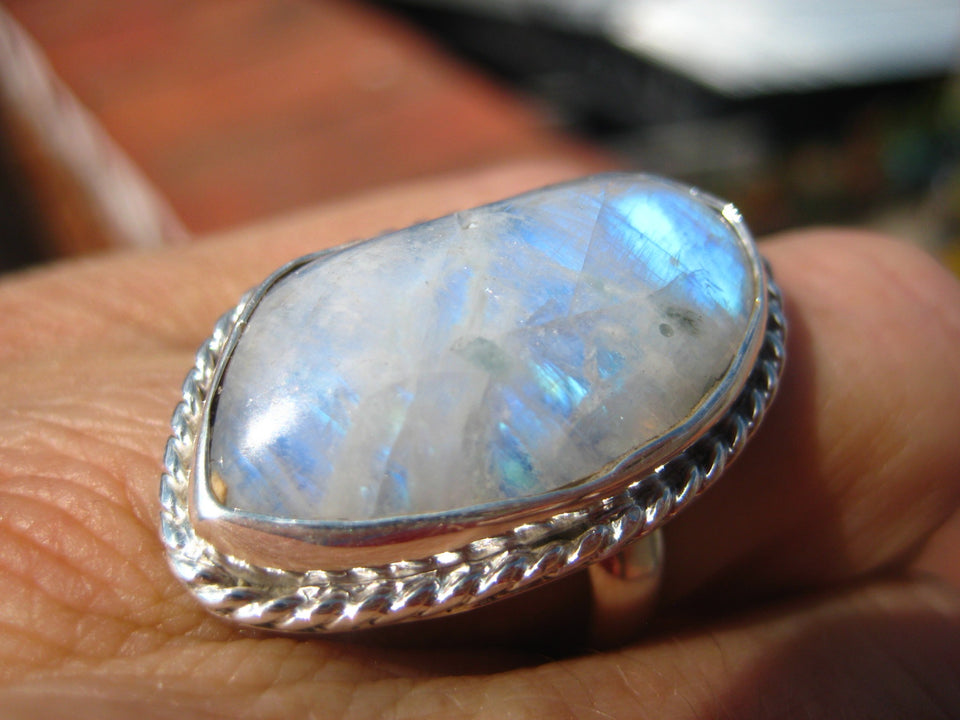Considering the internal characteristics and color play visible within the gemstone, what type of opal is featured in this ring, and how might these visual features impact its value? Based on the image, the gemstone appears to be a type of precious opal, likely a 'blue opal'. The dominant blue hues, along with flashes of other colors like green and orange, suggest a vibrant play-of-color, which is a hallmark of precious opals. These visual characteristics generally enhance the stone's value, as high-quality opals are prized for their brilliant and diverse color displays. Additionally, the size of the stone and the craftsmanship of its setting add to its overall appeal and market value. 